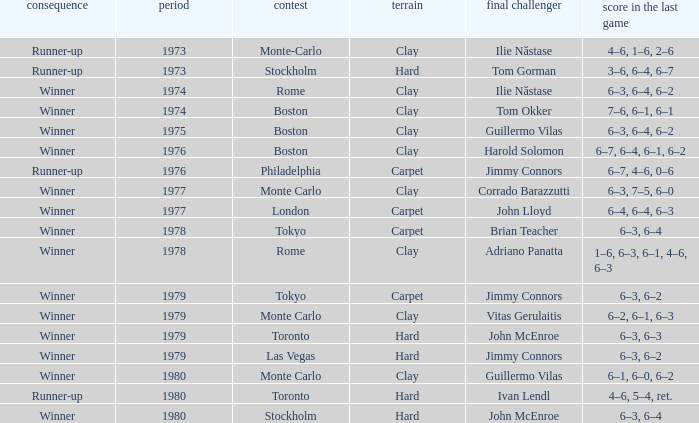Can you give me this table as a dict? {'header': ['consequence', 'period', 'contest', 'terrain', 'final challenger', 'score in the last game'], 'rows': [['Runner-up', '1973', 'Monte-Carlo', 'Clay', 'Ilie Năstase', '4–6, 1–6, 2–6'], ['Runner-up', '1973', 'Stockholm', 'Hard', 'Tom Gorman', '3–6, 6–4, 6–7'], ['Winner', '1974', 'Rome', 'Clay', 'Ilie Năstase', '6–3, 6–4, 6–2'], ['Winner', '1974', 'Boston', 'Clay', 'Tom Okker', '7–6, 6–1, 6–1'], ['Winner', '1975', 'Boston', 'Clay', 'Guillermo Vilas', '6–3, 6–4, 6–2'], ['Winner', '1976', 'Boston', 'Clay', 'Harold Solomon', '6–7, 6–4, 6–1, 6–2'], ['Runner-up', '1976', 'Philadelphia', 'Carpet', 'Jimmy Connors', '6–7, 4–6, 0–6'], ['Winner', '1977', 'Monte Carlo', 'Clay', 'Corrado Barazzutti', '6–3, 7–5, 6–0'], ['Winner', '1977', 'London', 'Carpet', 'John Lloyd', '6–4, 6–4, 6–3'], ['Winner', '1978', 'Tokyo', 'Carpet', 'Brian Teacher', '6–3, 6–4'], ['Winner', '1978', 'Rome', 'Clay', 'Adriano Panatta', '1–6, 6–3, 6–1, 4–6, 6–3'], ['Winner', '1979', 'Tokyo', 'Carpet', 'Jimmy Connors', '6–3, 6–2'], ['Winner', '1979', 'Monte Carlo', 'Clay', 'Vitas Gerulaitis', '6–2, 6–1, 6–3'], ['Winner', '1979', 'Toronto', 'Hard', 'John McEnroe', '6–3, 6–3'], ['Winner', '1979', 'Las Vegas', 'Hard', 'Jimmy Connors', '6–3, 6–2'], ['Winner', '1980', 'Monte Carlo', 'Clay', 'Guillermo Vilas', '6–1, 6–0, 6–2'], ['Runner-up', '1980', 'Toronto', 'Hard', 'Ivan Lendl', '4–6, 5–4, ret.'], ['Winner', '1980', 'Stockholm', 'Hard', 'John McEnroe', '6–3, 6–4']]} Name the surface for philadelphia Carpet. 